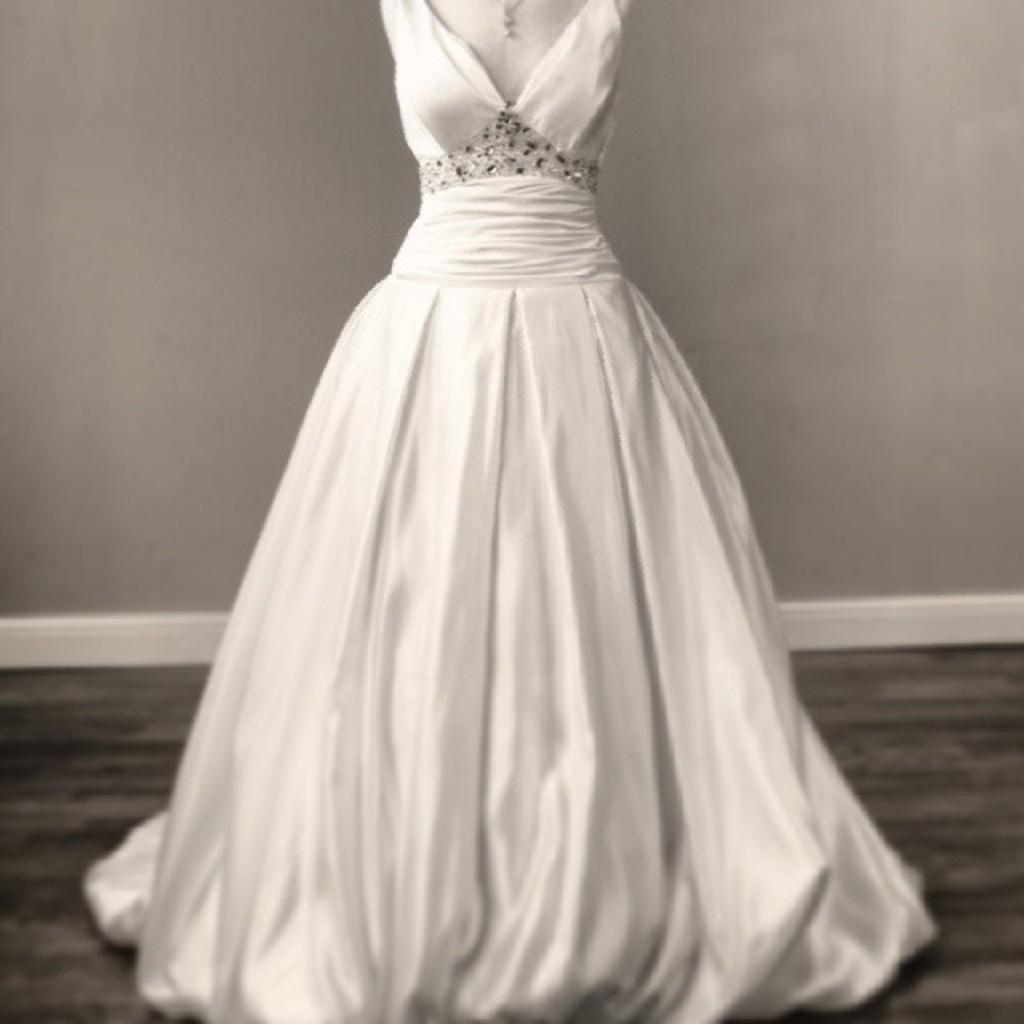What is the main subject in the foreground of the image? There is a white long gown in the foreground of the image. What can be seen in the background of the image? There is a wall in the background of the image. What is visible at the bottom of the image? There is a floor visible at the bottom of the image. What type of cream is being used to create the texture of the gown in the image? There is no cream being used to create the texture of the gown in the image; it is a photograph of a gown. What is the title of the image? The provided facts do not mention a title for the image. 